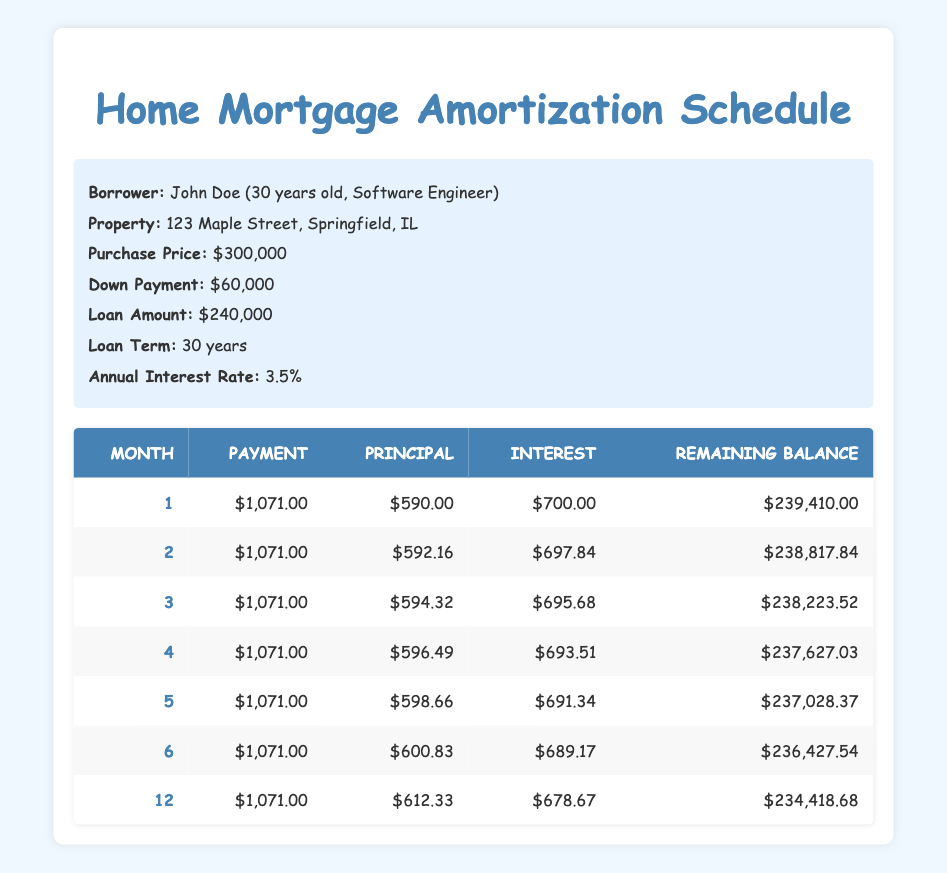What is the monthly payment amount for the mortgage? The monthly payment amount is listed in each row of the amortization schedule. It is consistently $1,071.00 for the first six months.
Answer: 1071.00 How much principal is paid off in the first month? The principal paid off is shown in the "Principal" column for month 1. It is $590.00.
Answer: 590.00 What is the interest paid in the second month? The interest paid is available in the "Interest" column for month 2, which states $697.84.
Answer: 697.84 What is the remaining balance of the mortgage after six months? The remaining balance after six months can be found in the schedule under the "Remaining Balance" column for month 6. It reads $236,427.54.
Answer: 236427.54 Is the monthly payment the same for all listed months? Yes, upon reviewing the "Payment" column for each month, it is clear that the payment amount remains consistent at $1,071.00.
Answer: Yes How much total principal has been paid off after the first six months? To find the total principal for the first six months, we add the principal amounts for each month: (590 + 592.16 + 594.32 + 596.49 + 598.66 + 600.83) = $3,172.46.
Answer: 3172.46 What is the total interest paid in the first 12 months if provided? Not all interest payments for the first 12 months are shown, but we can sum the interest payments for the six months provided to find a partial total. (700 + 697.84 + 695.68 + 693.51 + 691.34 + 689.17) = $4,267.54.
Answer: 4267.54 (Partial) How does the principal payment change from month 1 to month 12? To analyze this, we compare values from month 1 ($590.00) and month 12 ($612.33). The difference shows an increase in principal payment by $22.33.
Answer: Increased by 22.33 Is the interest payment higher than the principal payment in the first month? Yes, by comparing the values for month 1, the interest payment is $700.00, which is greater than the principal payment of $590.00.
Answer: Yes 